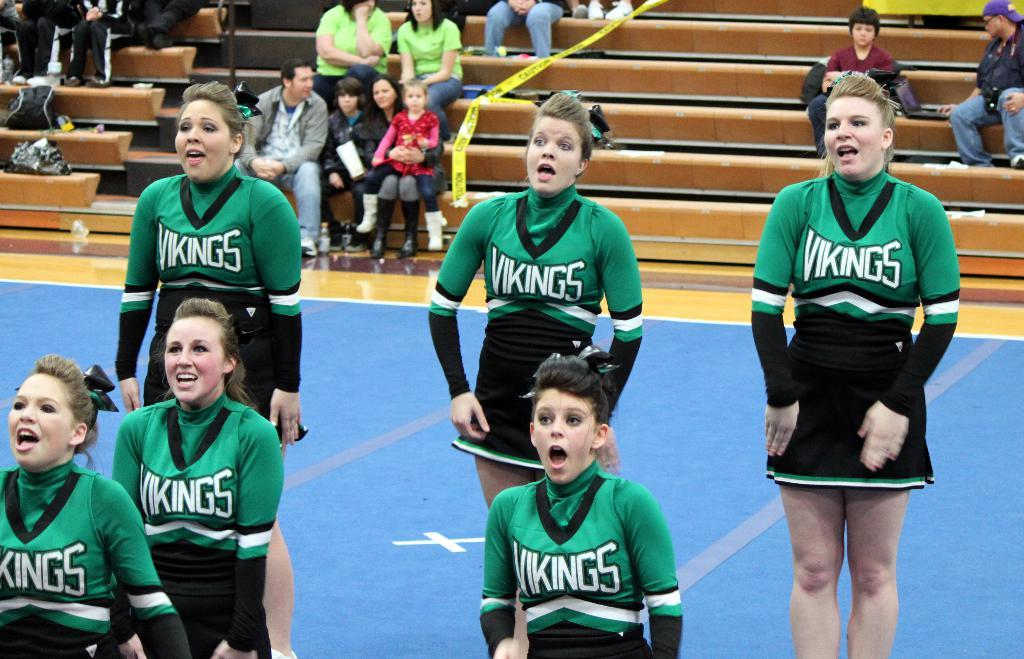<image>
Relay a brief, clear account of the picture shown. Cheerleaders wearing green and black with the word Vikings on the chest. 